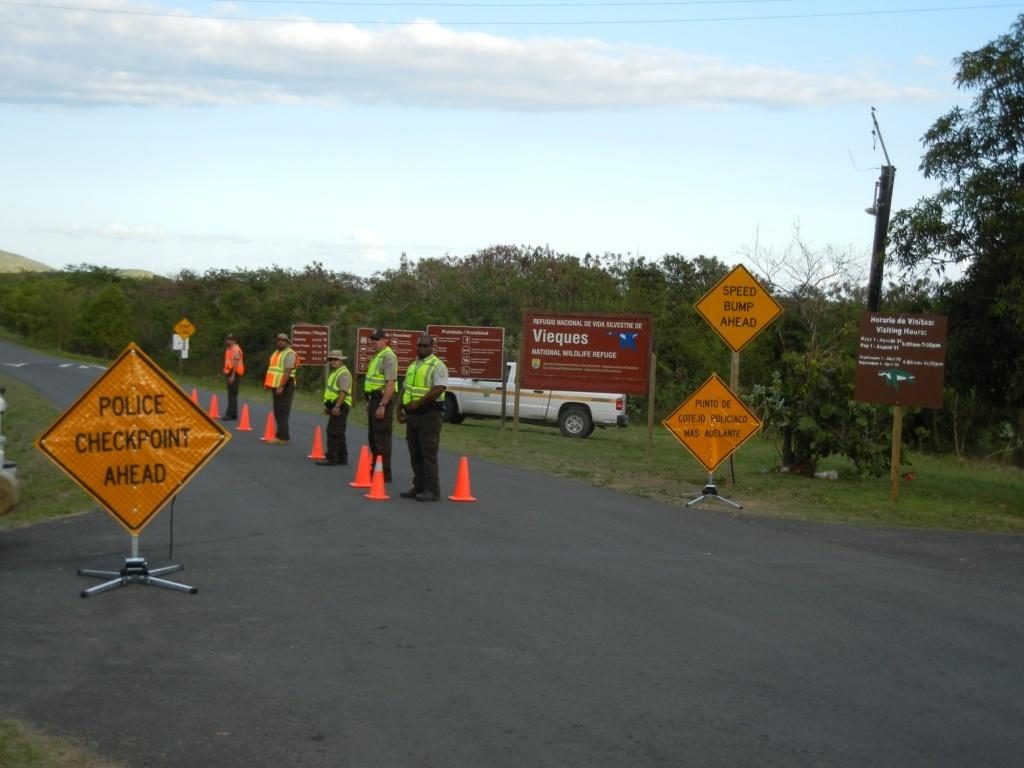<image>
Relay a brief, clear account of the picture shown. Five police officers standing at a checkpoint, in front of a yello sign that says Police Checkpoint Ahead. 